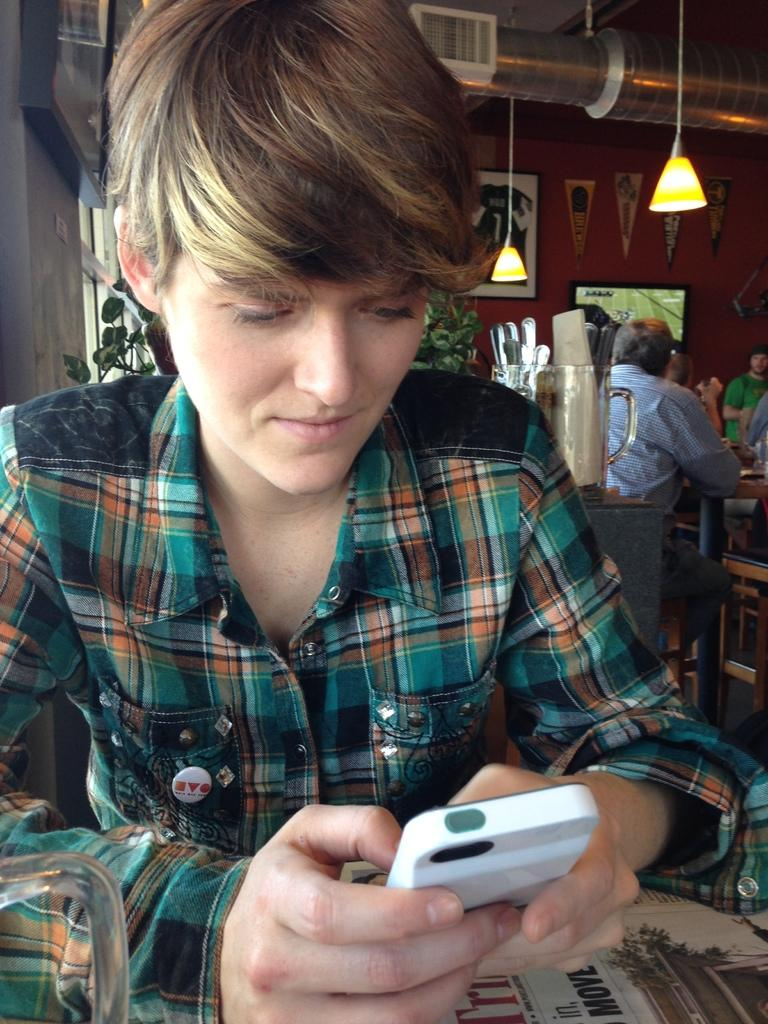Who is the main subject in the image? There is a boy in the image. What is the boy doing in the image? The boy is sitting at a table. What is the boy holding in his hands? The boy is holding a mobile in his hands. What type of butter is the boy using to write on the table in the image? There is no butter present in the image, and the boy is not writing on the table. 